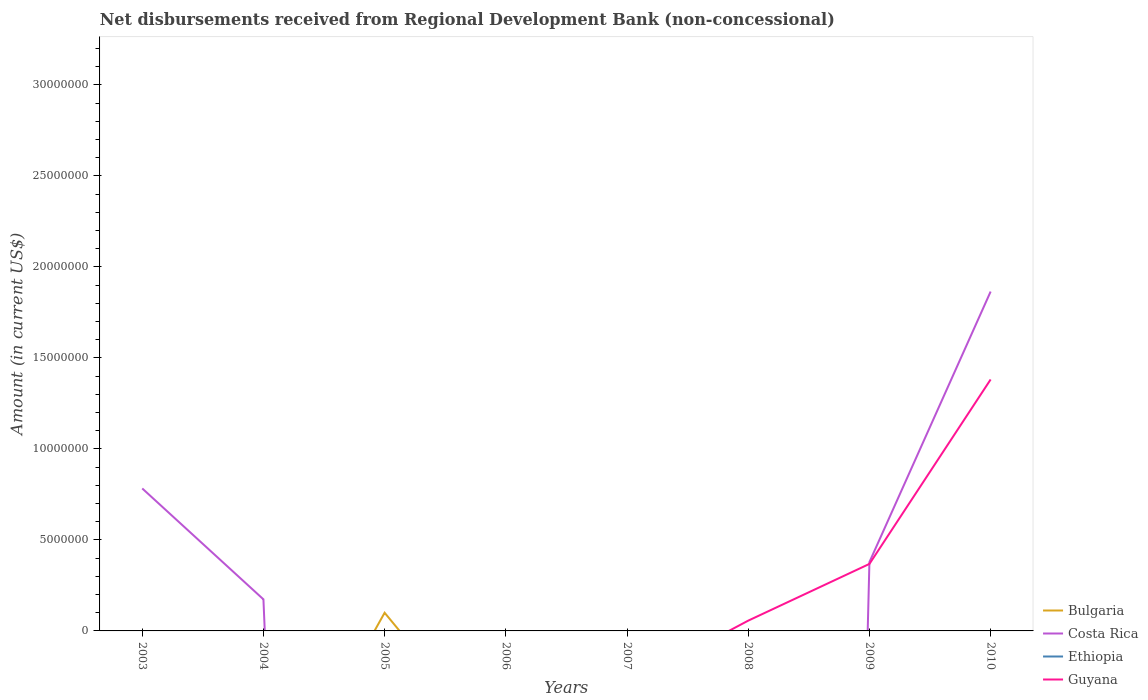Does the line corresponding to Bulgaria intersect with the line corresponding to Guyana?
Keep it short and to the point. Yes. Is the number of lines equal to the number of legend labels?
Your response must be concise. No. What is the total amount of disbursements received from Regional Development Bank in Costa Rica in the graph?
Provide a short and direct response. 6.09e+06. What is the difference between the highest and the second highest amount of disbursements received from Regional Development Bank in Costa Rica?
Your answer should be compact. 1.86e+07. What is the difference between the highest and the lowest amount of disbursements received from Regional Development Bank in Guyana?
Provide a succinct answer. 2. How many lines are there?
Keep it short and to the point. 3. How many years are there in the graph?
Offer a terse response. 8. Are the values on the major ticks of Y-axis written in scientific E-notation?
Ensure brevity in your answer.  No. Does the graph contain any zero values?
Make the answer very short. Yes. How many legend labels are there?
Keep it short and to the point. 4. How are the legend labels stacked?
Your response must be concise. Vertical. What is the title of the graph?
Provide a short and direct response. Net disbursements received from Regional Development Bank (non-concessional). Does "Dominica" appear as one of the legend labels in the graph?
Provide a succinct answer. No. What is the Amount (in current US$) of Bulgaria in 2003?
Give a very brief answer. 0. What is the Amount (in current US$) of Costa Rica in 2003?
Provide a succinct answer. 7.83e+06. What is the Amount (in current US$) in Ethiopia in 2003?
Offer a terse response. 0. What is the Amount (in current US$) in Guyana in 2003?
Your response must be concise. 0. What is the Amount (in current US$) of Costa Rica in 2004?
Your answer should be compact. 1.74e+06. What is the Amount (in current US$) in Bulgaria in 2005?
Provide a succinct answer. 9.98e+05. What is the Amount (in current US$) in Ethiopia in 2005?
Your answer should be very brief. 0. What is the Amount (in current US$) in Guyana in 2005?
Your response must be concise. 0. What is the Amount (in current US$) in Bulgaria in 2007?
Your answer should be compact. 0. What is the Amount (in current US$) of Costa Rica in 2007?
Your response must be concise. 0. What is the Amount (in current US$) of Ethiopia in 2007?
Provide a short and direct response. 0. What is the Amount (in current US$) in Costa Rica in 2008?
Keep it short and to the point. 0. What is the Amount (in current US$) in Ethiopia in 2008?
Your answer should be compact. 0. What is the Amount (in current US$) of Guyana in 2008?
Keep it short and to the point. 5.65e+05. What is the Amount (in current US$) in Costa Rica in 2009?
Your answer should be compact. 3.78e+06. What is the Amount (in current US$) of Guyana in 2009?
Give a very brief answer. 3.68e+06. What is the Amount (in current US$) in Bulgaria in 2010?
Make the answer very short. 0. What is the Amount (in current US$) of Costa Rica in 2010?
Provide a succinct answer. 1.86e+07. What is the Amount (in current US$) in Guyana in 2010?
Offer a very short reply. 1.38e+07. Across all years, what is the maximum Amount (in current US$) in Bulgaria?
Offer a very short reply. 9.98e+05. Across all years, what is the maximum Amount (in current US$) in Costa Rica?
Offer a terse response. 1.86e+07. Across all years, what is the maximum Amount (in current US$) of Guyana?
Ensure brevity in your answer.  1.38e+07. What is the total Amount (in current US$) in Bulgaria in the graph?
Keep it short and to the point. 9.98e+05. What is the total Amount (in current US$) of Costa Rica in the graph?
Provide a succinct answer. 3.20e+07. What is the total Amount (in current US$) of Guyana in the graph?
Your answer should be very brief. 1.81e+07. What is the difference between the Amount (in current US$) in Costa Rica in 2003 and that in 2004?
Provide a short and direct response. 6.09e+06. What is the difference between the Amount (in current US$) of Costa Rica in 2003 and that in 2009?
Ensure brevity in your answer.  4.05e+06. What is the difference between the Amount (in current US$) of Costa Rica in 2003 and that in 2010?
Keep it short and to the point. -1.08e+07. What is the difference between the Amount (in current US$) in Costa Rica in 2004 and that in 2009?
Offer a very short reply. -2.05e+06. What is the difference between the Amount (in current US$) of Costa Rica in 2004 and that in 2010?
Ensure brevity in your answer.  -1.69e+07. What is the difference between the Amount (in current US$) in Guyana in 2008 and that in 2009?
Provide a succinct answer. -3.12e+06. What is the difference between the Amount (in current US$) of Guyana in 2008 and that in 2010?
Provide a succinct answer. -1.32e+07. What is the difference between the Amount (in current US$) of Costa Rica in 2009 and that in 2010?
Your answer should be compact. -1.49e+07. What is the difference between the Amount (in current US$) of Guyana in 2009 and that in 2010?
Your answer should be very brief. -1.01e+07. What is the difference between the Amount (in current US$) of Costa Rica in 2003 and the Amount (in current US$) of Guyana in 2008?
Ensure brevity in your answer.  7.26e+06. What is the difference between the Amount (in current US$) of Costa Rica in 2003 and the Amount (in current US$) of Guyana in 2009?
Keep it short and to the point. 4.15e+06. What is the difference between the Amount (in current US$) of Costa Rica in 2003 and the Amount (in current US$) of Guyana in 2010?
Offer a very short reply. -5.99e+06. What is the difference between the Amount (in current US$) of Costa Rica in 2004 and the Amount (in current US$) of Guyana in 2008?
Provide a succinct answer. 1.17e+06. What is the difference between the Amount (in current US$) in Costa Rica in 2004 and the Amount (in current US$) in Guyana in 2009?
Provide a short and direct response. -1.95e+06. What is the difference between the Amount (in current US$) in Costa Rica in 2004 and the Amount (in current US$) in Guyana in 2010?
Give a very brief answer. -1.21e+07. What is the difference between the Amount (in current US$) in Bulgaria in 2005 and the Amount (in current US$) in Guyana in 2008?
Your answer should be very brief. 4.33e+05. What is the difference between the Amount (in current US$) of Bulgaria in 2005 and the Amount (in current US$) of Costa Rica in 2009?
Offer a terse response. -2.78e+06. What is the difference between the Amount (in current US$) of Bulgaria in 2005 and the Amount (in current US$) of Guyana in 2009?
Give a very brief answer. -2.68e+06. What is the difference between the Amount (in current US$) in Bulgaria in 2005 and the Amount (in current US$) in Costa Rica in 2010?
Your answer should be very brief. -1.76e+07. What is the difference between the Amount (in current US$) of Bulgaria in 2005 and the Amount (in current US$) of Guyana in 2010?
Your answer should be very brief. -1.28e+07. What is the difference between the Amount (in current US$) of Costa Rica in 2009 and the Amount (in current US$) of Guyana in 2010?
Keep it short and to the point. -1.00e+07. What is the average Amount (in current US$) of Bulgaria per year?
Your response must be concise. 1.25e+05. What is the average Amount (in current US$) of Costa Rica per year?
Your response must be concise. 4.00e+06. What is the average Amount (in current US$) of Guyana per year?
Offer a terse response. 2.26e+06. In the year 2009, what is the difference between the Amount (in current US$) in Costa Rica and Amount (in current US$) in Guyana?
Your answer should be very brief. 1.01e+05. In the year 2010, what is the difference between the Amount (in current US$) of Costa Rica and Amount (in current US$) of Guyana?
Give a very brief answer. 4.83e+06. What is the ratio of the Amount (in current US$) of Costa Rica in 2003 to that in 2004?
Your answer should be compact. 4.51. What is the ratio of the Amount (in current US$) in Costa Rica in 2003 to that in 2009?
Provide a succinct answer. 2.07. What is the ratio of the Amount (in current US$) of Costa Rica in 2003 to that in 2010?
Offer a terse response. 0.42. What is the ratio of the Amount (in current US$) of Costa Rica in 2004 to that in 2009?
Your response must be concise. 0.46. What is the ratio of the Amount (in current US$) in Costa Rica in 2004 to that in 2010?
Provide a short and direct response. 0.09. What is the ratio of the Amount (in current US$) in Guyana in 2008 to that in 2009?
Keep it short and to the point. 0.15. What is the ratio of the Amount (in current US$) in Guyana in 2008 to that in 2010?
Make the answer very short. 0.04. What is the ratio of the Amount (in current US$) in Costa Rica in 2009 to that in 2010?
Your answer should be compact. 0.2. What is the ratio of the Amount (in current US$) in Guyana in 2009 to that in 2010?
Your answer should be very brief. 0.27. What is the difference between the highest and the second highest Amount (in current US$) in Costa Rica?
Offer a very short reply. 1.08e+07. What is the difference between the highest and the second highest Amount (in current US$) in Guyana?
Your response must be concise. 1.01e+07. What is the difference between the highest and the lowest Amount (in current US$) in Bulgaria?
Your answer should be very brief. 9.98e+05. What is the difference between the highest and the lowest Amount (in current US$) in Costa Rica?
Ensure brevity in your answer.  1.86e+07. What is the difference between the highest and the lowest Amount (in current US$) of Guyana?
Your answer should be compact. 1.38e+07. 